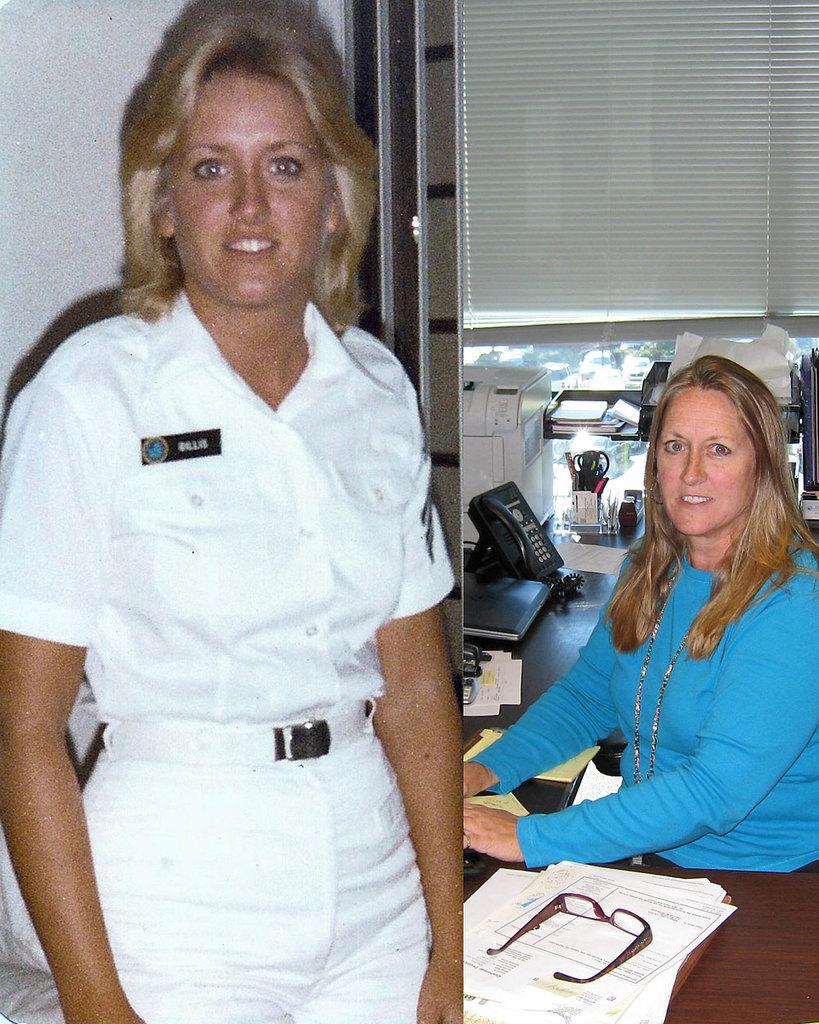In one or two sentences, can you explain what this image depicts? This is a collage in this image on the left side there is one woman who is standing and smiling and she is wearing a uniform. And on the right side there is one woman who is sitting in front of her there is table. On the table there are some papers, books, telephone, spectacles, pens and some other objects and there is a window and blinds and on the left side there is wall. 